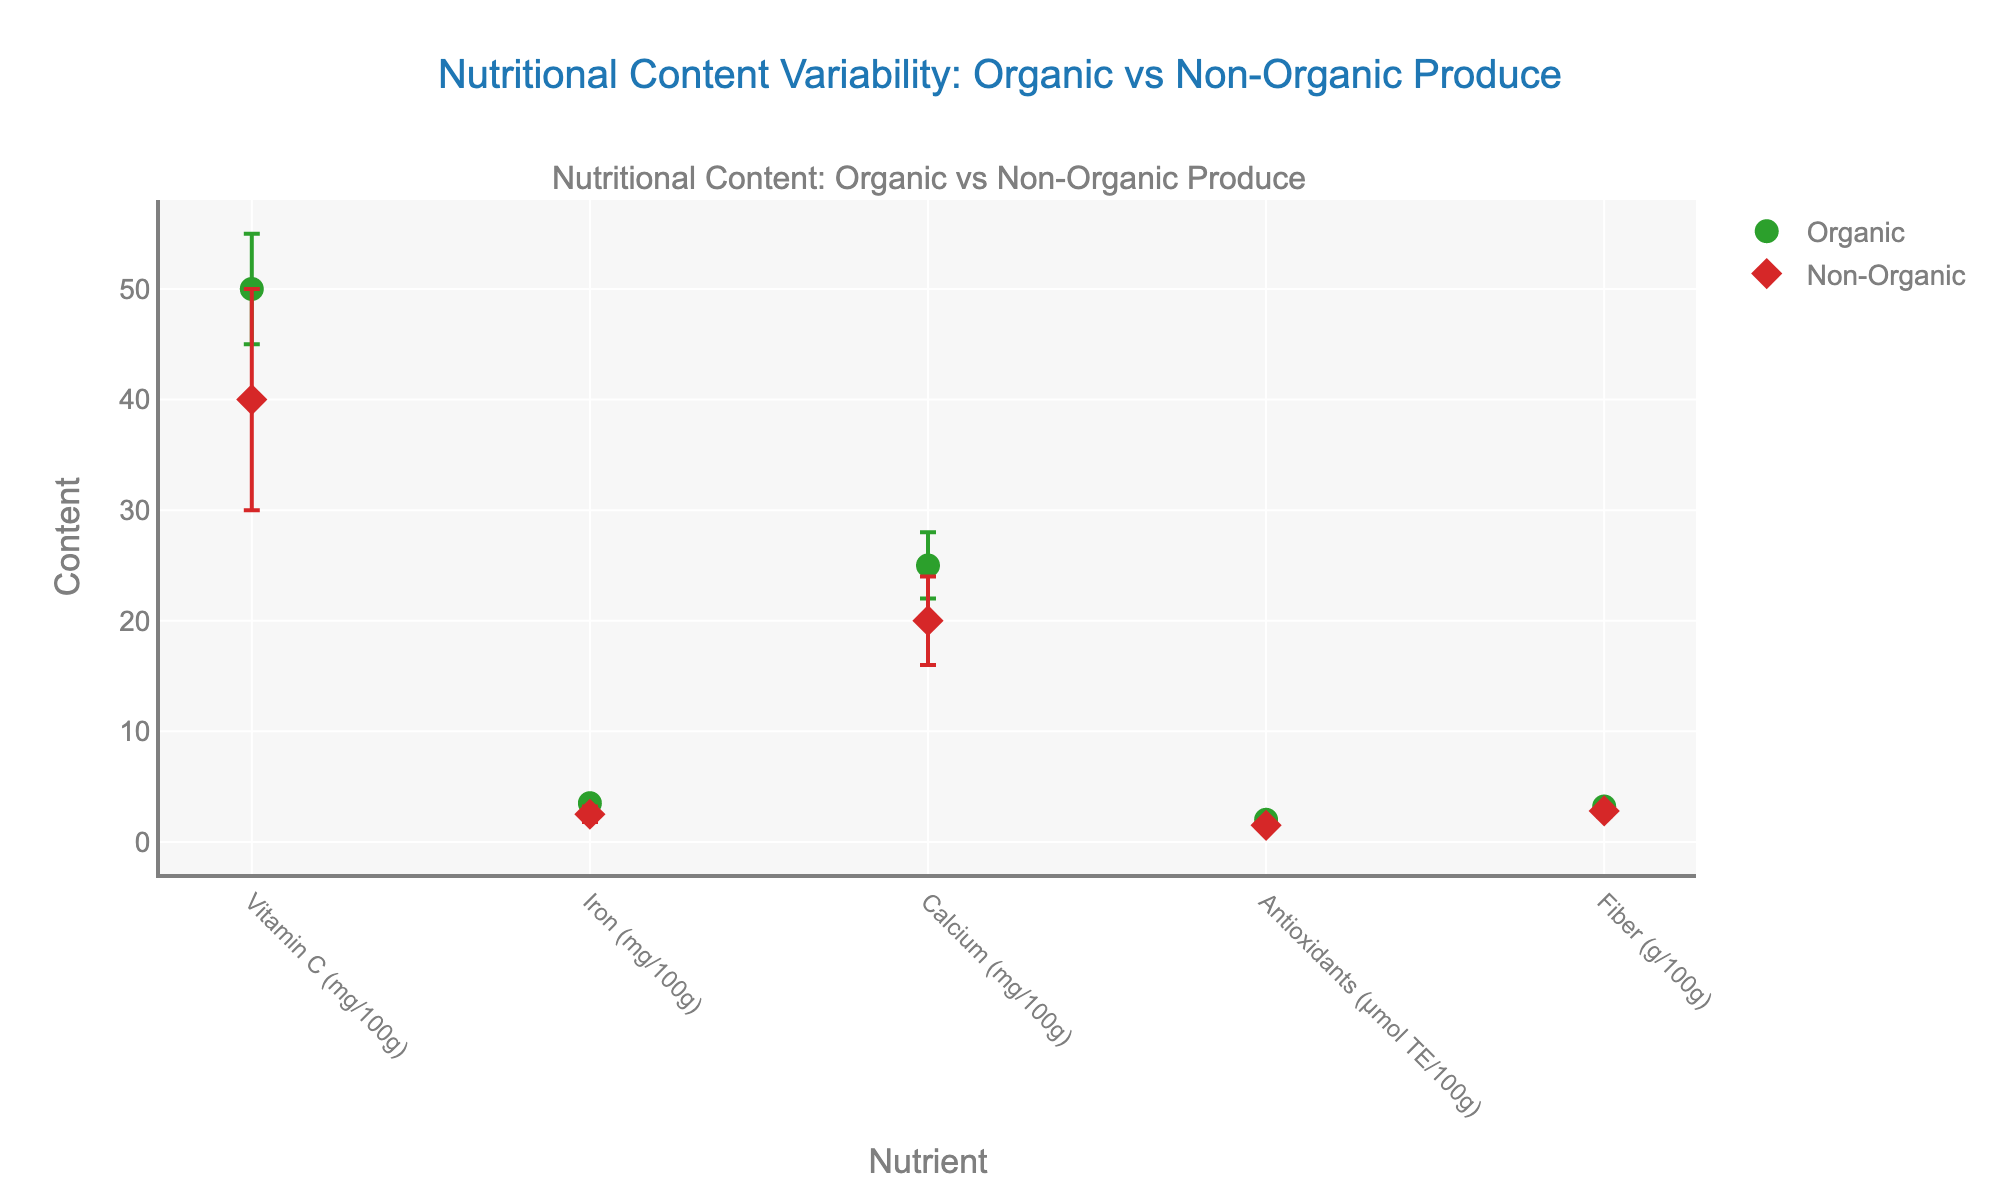What's the title of the figure? The title is written at the top center of the figure and usually summarizes the main topic or finding. In this case, it indicates a comparison between organic and non-organic produce.
Answer: Nutritional Content Variability: Organic vs Non-Organic Produce What nutrient shows the highest average content in organic produce? To find this, look at the highest dot along the y-axis within the markers labeled 'Organic.'
Answer: Vitamin C (50 mg/100g) What is the difference in average Vitamin C content between organic and non-organic produce? The average content for organic produce is 50 mg/100g, and for non-organic produce, it is 40 mg/100g. Subtract the latter from the former.
Answer: 10 mg/100g Which type of produce, organic or non-organic, has a higher variability in Calcium content? Variability is represented by the length of the error bars; longer bars indicate higher variability. Compare the error bars for Calcium between organic and non-organic produce.
Answer: Non-Organic How does the average antioxidant content in organic produce compare to non-organic produce? Compare the height of the dots labeled 'Antioxidants (µmol TE/100g)' for both organic and non-organic produce. The organic has an average of 2 µmol TE/100g and non-organic has 1.5 µmol TE/100g.
Answer: Higher in organic What is the standard deviation for Iron content in non-organic produce? The standard deviation for each nutrient is given in the data. For non-organic Iron, it is 0.7 mg/100g.
Answer: 0.7 mg/100g Between which two nutrients is the spread of average content the smallest for organic produce? Look at the vertical distance between dots for organic produce; the smallest gap will indicate the smallest spread.
Answer: Iron and Antioxidants How much higher is the average Fiber content in organic produce compared to non-organic produce? The average Fiber content for organic produce is 3.2 g/100g, and for non-organic, it is 2.8 g/100g. Subtract the latter from the former.
Answer: 0.4 g/100g Is there any nutrient for which the average content and the variability (standard deviation) are both higher in non-organic produce? Check each nutrient and compare both the average content and the length of the error bars between organic and non-organic produce.
Answer: Vitamin C What does the error bar represent in this figure? In the context of this figure, the error bar represents the standard deviation of the nutrient content, indicating the variability or spread around the average value.
Answer: Standard deviation 